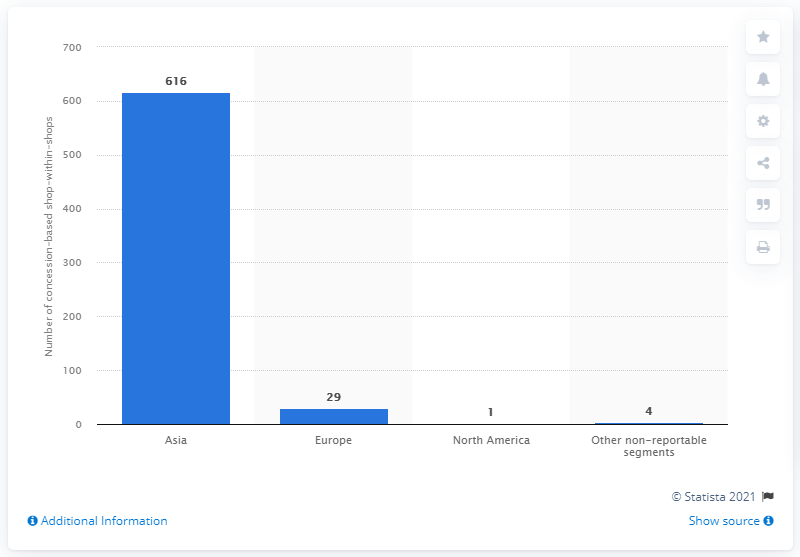Give some essential details in this illustration. Polo Ralph Lauren operated 616 concession-based shop-within-shops as of 2021. 